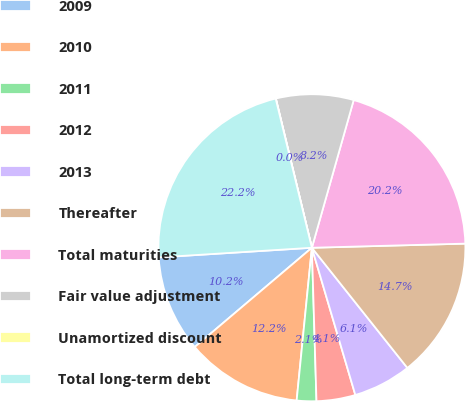Convert chart. <chart><loc_0><loc_0><loc_500><loc_500><pie_chart><fcel>2009<fcel>2010<fcel>2011<fcel>2012<fcel>2013<fcel>Thereafter<fcel>Total maturities<fcel>Fair value adjustment<fcel>Unamortized discount<fcel>Total long-term debt<nl><fcel>10.19%<fcel>12.23%<fcel>2.06%<fcel>4.09%<fcel>6.12%<fcel>14.74%<fcel>20.18%<fcel>8.16%<fcel>0.02%<fcel>22.21%<nl></chart> 